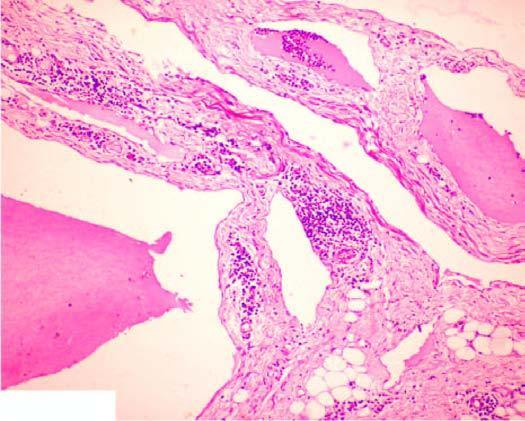does an intimal tear show scattered collection of lymphocytes?
Answer the question using a single word or phrase. No 